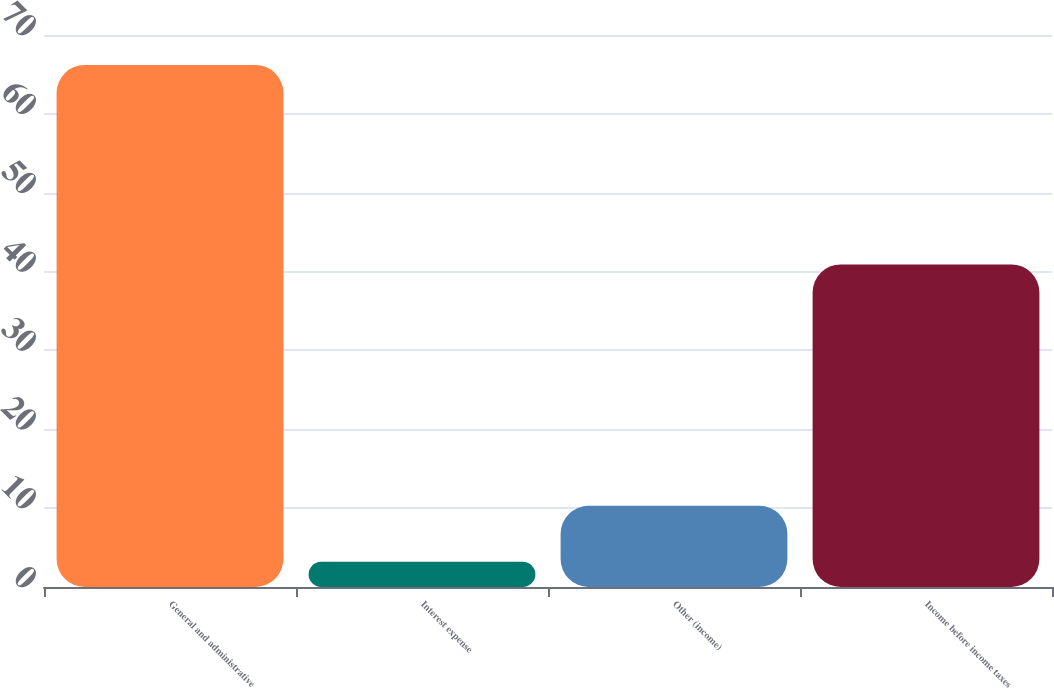Convert chart to OTSL. <chart><loc_0><loc_0><loc_500><loc_500><bar_chart><fcel>General and administrative<fcel>Interest expense<fcel>Other (income)<fcel>Income before income taxes<nl><fcel>66.2<fcel>3.2<fcel>10.3<fcel>40.9<nl></chart> 